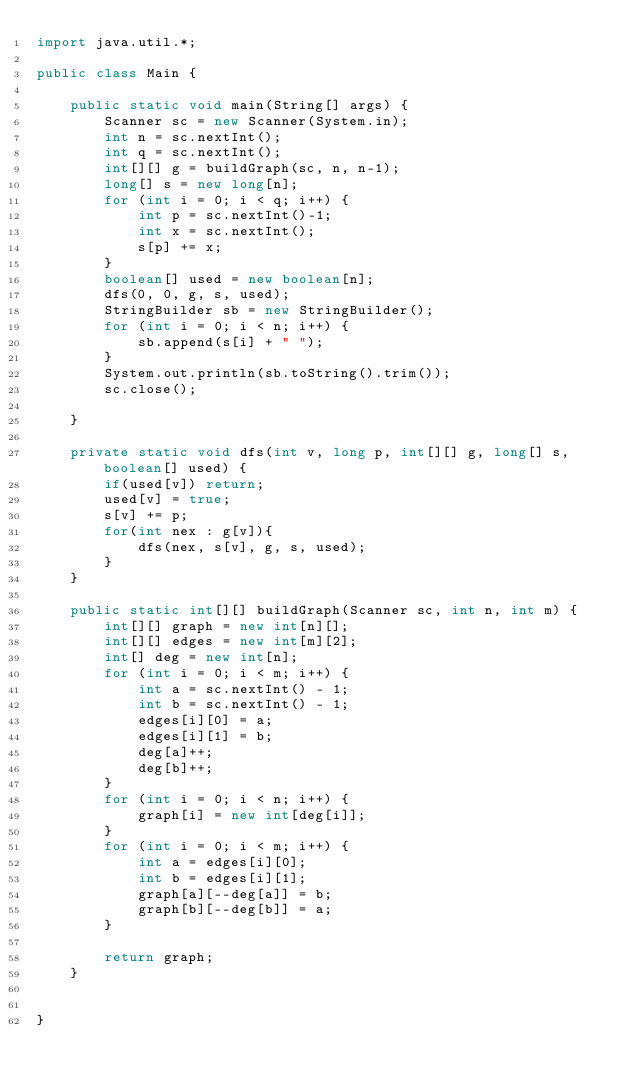Convert code to text. <code><loc_0><loc_0><loc_500><loc_500><_Java_>import java.util.*;

public class Main {

    public static void main(String[] args) {
        Scanner sc = new Scanner(System.in);
        int n = sc.nextInt();
        int q = sc.nextInt();
        int[][] g = buildGraph(sc, n, n-1);
        long[] s = new long[n];
        for (int i = 0; i < q; i++) {
            int p = sc.nextInt()-1;
            int x = sc.nextInt();
            s[p] += x;
        }
        boolean[] used = new boolean[n];
        dfs(0, 0, g, s, used);
        StringBuilder sb = new StringBuilder();
        for (int i = 0; i < n; i++) {
            sb.append(s[i] + " ");
        }
        System.out.println(sb.toString().trim());
        sc.close();

    }

    private static void dfs(int v, long p, int[][] g, long[] s, boolean[] used) {
        if(used[v]) return;
        used[v] = true;
        s[v] += p;
        for(int nex : g[v]){
            dfs(nex, s[v], g, s, used);
        }
    }

    public static int[][] buildGraph(Scanner sc, int n, int m) {
        int[][] graph = new int[n][];
        int[][] edges = new int[m][2];
        int[] deg = new int[n];
        for (int i = 0; i < m; i++) {
            int a = sc.nextInt() - 1;
            int b = sc.nextInt() - 1;
            edges[i][0] = a;
            edges[i][1] = b;
            deg[a]++;
            deg[b]++;
        }
        for (int i = 0; i < n; i++) {
            graph[i] = new int[deg[i]];
        }
        for (int i = 0; i < m; i++) {
            int a = edges[i][0];
            int b = edges[i][1];
            graph[a][--deg[a]] = b;
            graph[b][--deg[b]] = a;
        }

        return graph;
    }


}
</code> 